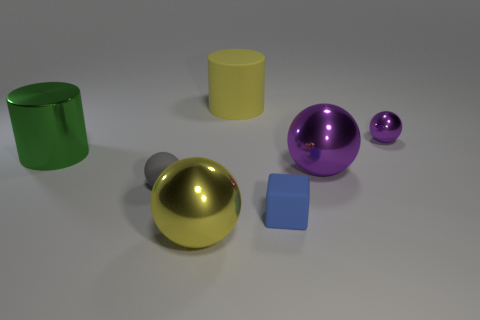Are there fewer rubber blocks behind the small gray matte object than big purple balls that are on the right side of the large purple metallic thing?
Give a very brief answer. No. Is there a cube that has the same color as the small matte ball?
Give a very brief answer. No. Is the gray thing made of the same material as the big object that is behind the green thing?
Offer a very short reply. Yes. There is a large ball left of the blue rubber object; is there a big yellow metal object on the right side of it?
Provide a succinct answer. No. There is a big metallic thing that is behind the blue matte block and on the right side of the small matte sphere; what color is it?
Give a very brief answer. Purple. How big is the gray rubber object?
Provide a short and direct response. Small. How many yellow shiny balls are the same size as the green shiny cylinder?
Your response must be concise. 1. Does the big yellow object behind the big yellow metallic object have the same material as the ball that is in front of the blue object?
Your answer should be compact. No. The yellow thing behind the tiny object that is left of the yellow rubber cylinder is made of what material?
Keep it short and to the point. Rubber. There is a ball behind the green object; what is its material?
Make the answer very short. Metal. 